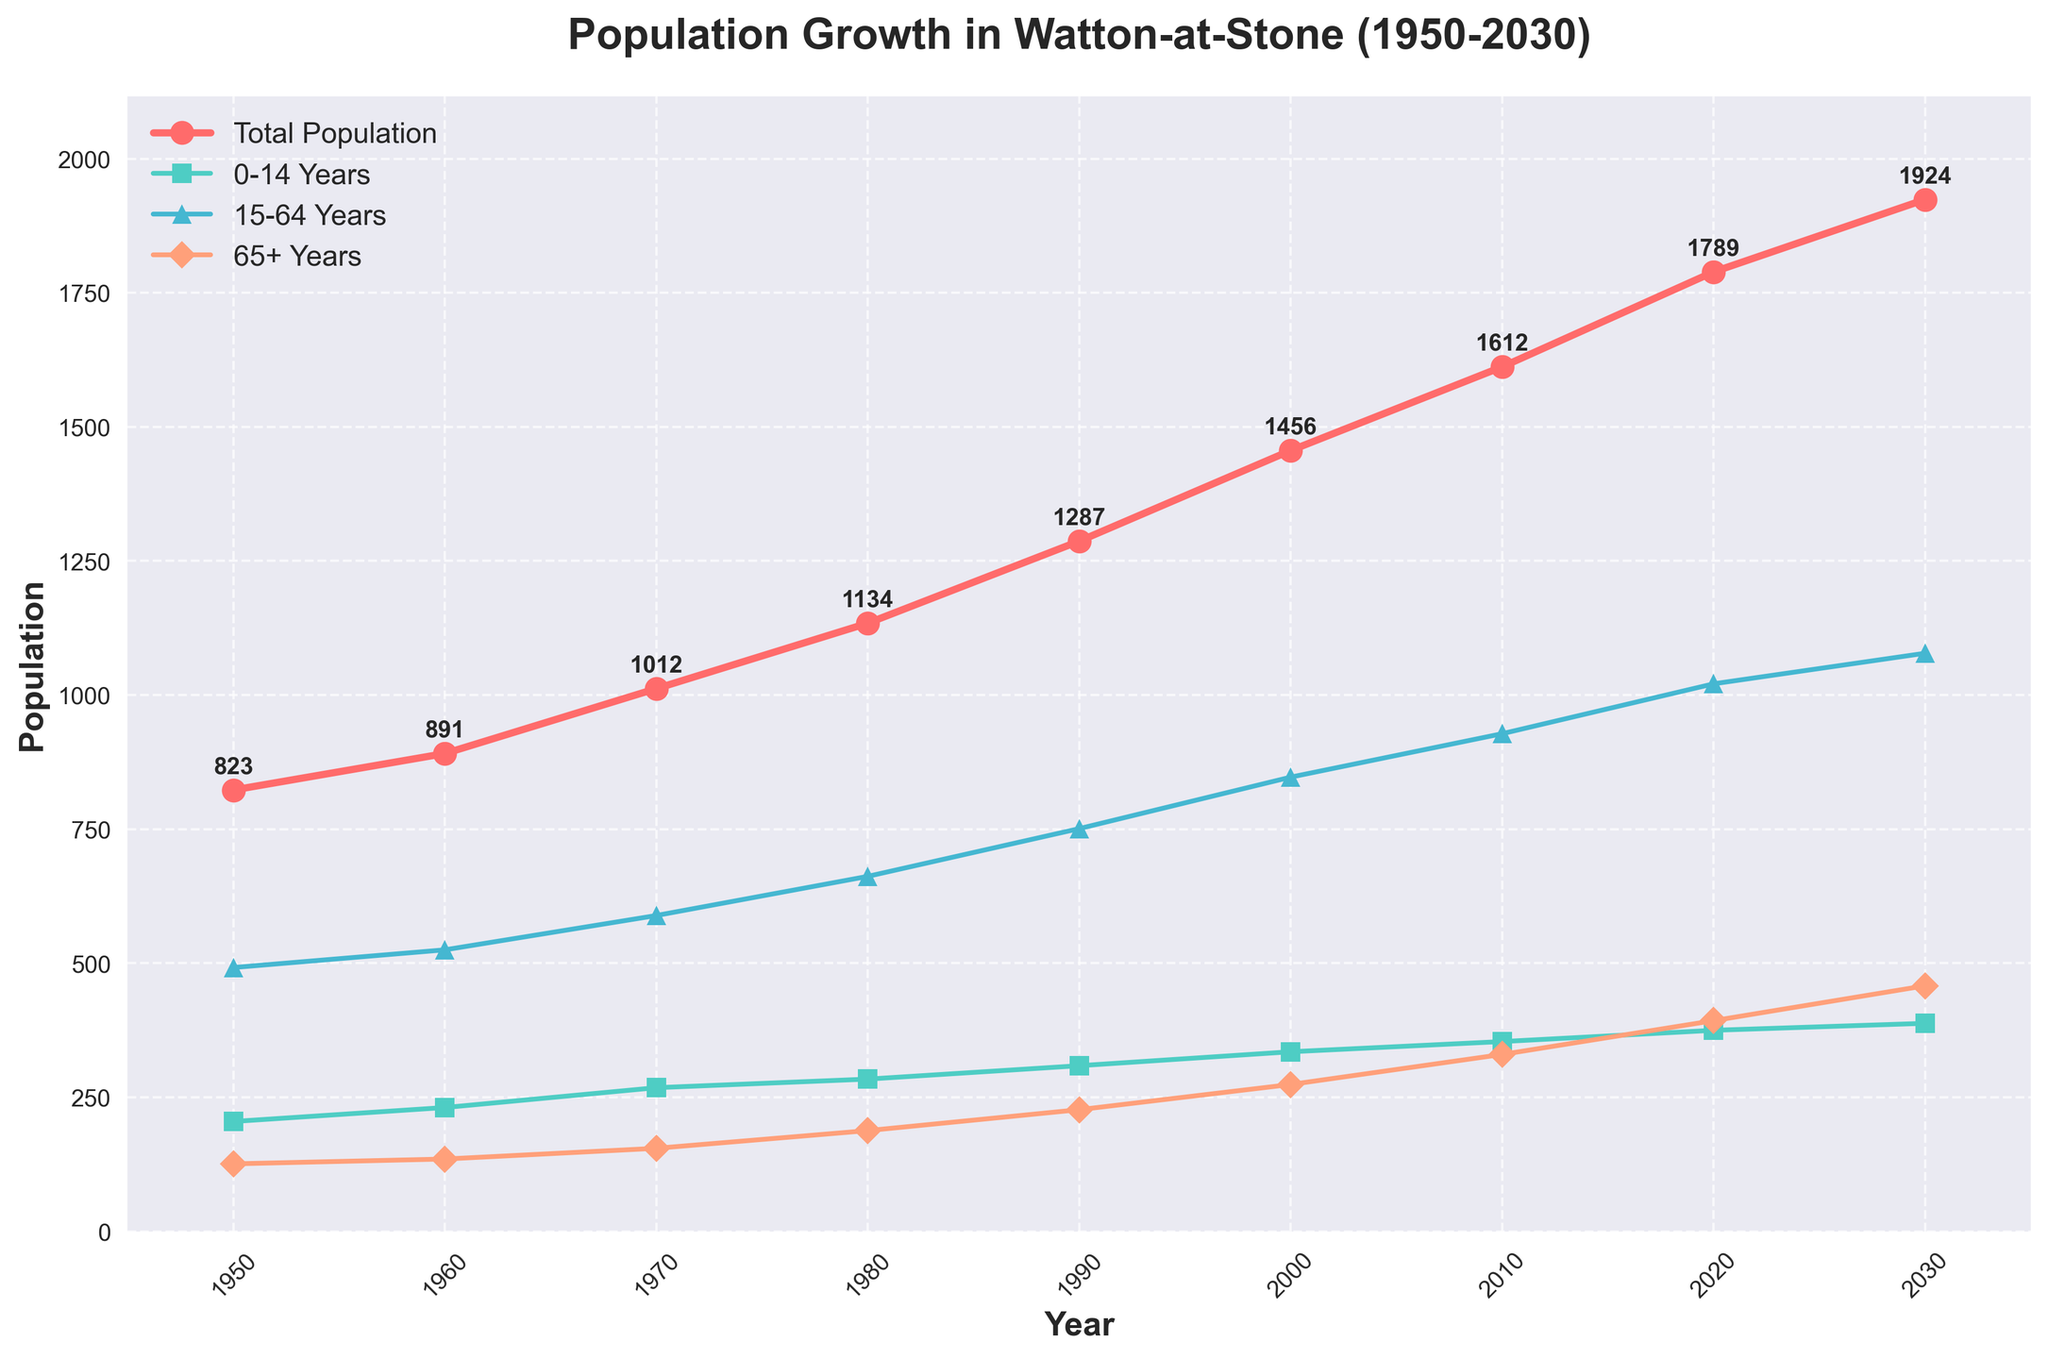How has the total population changed from 1950 to 2020? Observe the increase in the total population line, which starts at 823 in 1950 and reaches 1789 in 2020. The difference between the two populations is calculated as 1789 - 823.
Answer: The population increased by 966 Which age group showed the most significant growth between 1950 and 2020? Compare the growth of each age group by looking at the endpoints on the plot. The 0-14 Years group increased from 205 to 375. The 15-64 Years group increased from 492 to 1021. The 65+ Years group increased from 126 to 393. Calculate the differences for each group and identify the largest increase.
Answer: The 15-64 Years group grew the most (529) By what amount did the elderly population (65+ Years) increase from 2000 to 2030? Look at the population for the 65+ Years group in 2000 and 2030, which are 274 and 458, respectively. Subtract the earlier value from the later value, 458 - 274.
Answer: The elderly population increased by 184 Between which two decades did the total population see the largest percentage increase? Calculate the percentage increase for each decade: 1950-1960, 1960-1970, 1970-1980, 1980-1990, 1990-2000, 2000-2010, and 2010-2020. Use (New Population - Old Population) / Old Population * 100 for each interval and compare the results.
Answer: The largest percentage increase was from 1960 to 1970 In 2030, which age group is projected to have the smallest population? Look at the 2030 data points for each age group. The populations for the 0-14 Years, 15-64 Years, and 65+ Years groups are 388, 1078, and 458, respectively. Identify the smallest value.
Answer: The 0-14 Years group has the smallest population In which decade did the 0-14 Years age group experience the smallest increase? Calculate the increase for the 0-14 Years group for each decade: 1950-1960, 1960-1970, 1970-1980, 1980-1990, 1990-2000, 2000-2010, and 2010-2020. Compare these values to find the smallest increase.
Answer: The smallest increase occurred between 1960 and 1970 (37) What is the difference in the working-age population (15-64 Years) between 1980 and 2020? Look at the population for the 15-64 Years group in 1980 (662) and 2020 (1021). Subtract the 1980 value from the 2020 value: 1021 - 662.
Answer: The difference is 359 What are the colors representing each age group in the plot? Examine the legend to identify the colors associated with each age group: 0-14 Years, 15-64 Years, and 65+ Years. The colors are provided in the legend.
Answer: 0-14 Years: green, 15-64 Years: blue, 65+ Years: orange What trend do you observe for the elderly population (65+ Years) from 1950 to 2030? Observe the line representing the 65+ Years age group from 1950 to 2030. Note that it consistently rises, indicating a steady increase in the elderly population over the entire period.
Answer: Increasing trend Which year had the highest total population from the given data? Identify the highest point on the total population line. The year corresponding to the highest value is 2030, with a population of 1924.
Answer: 2030 